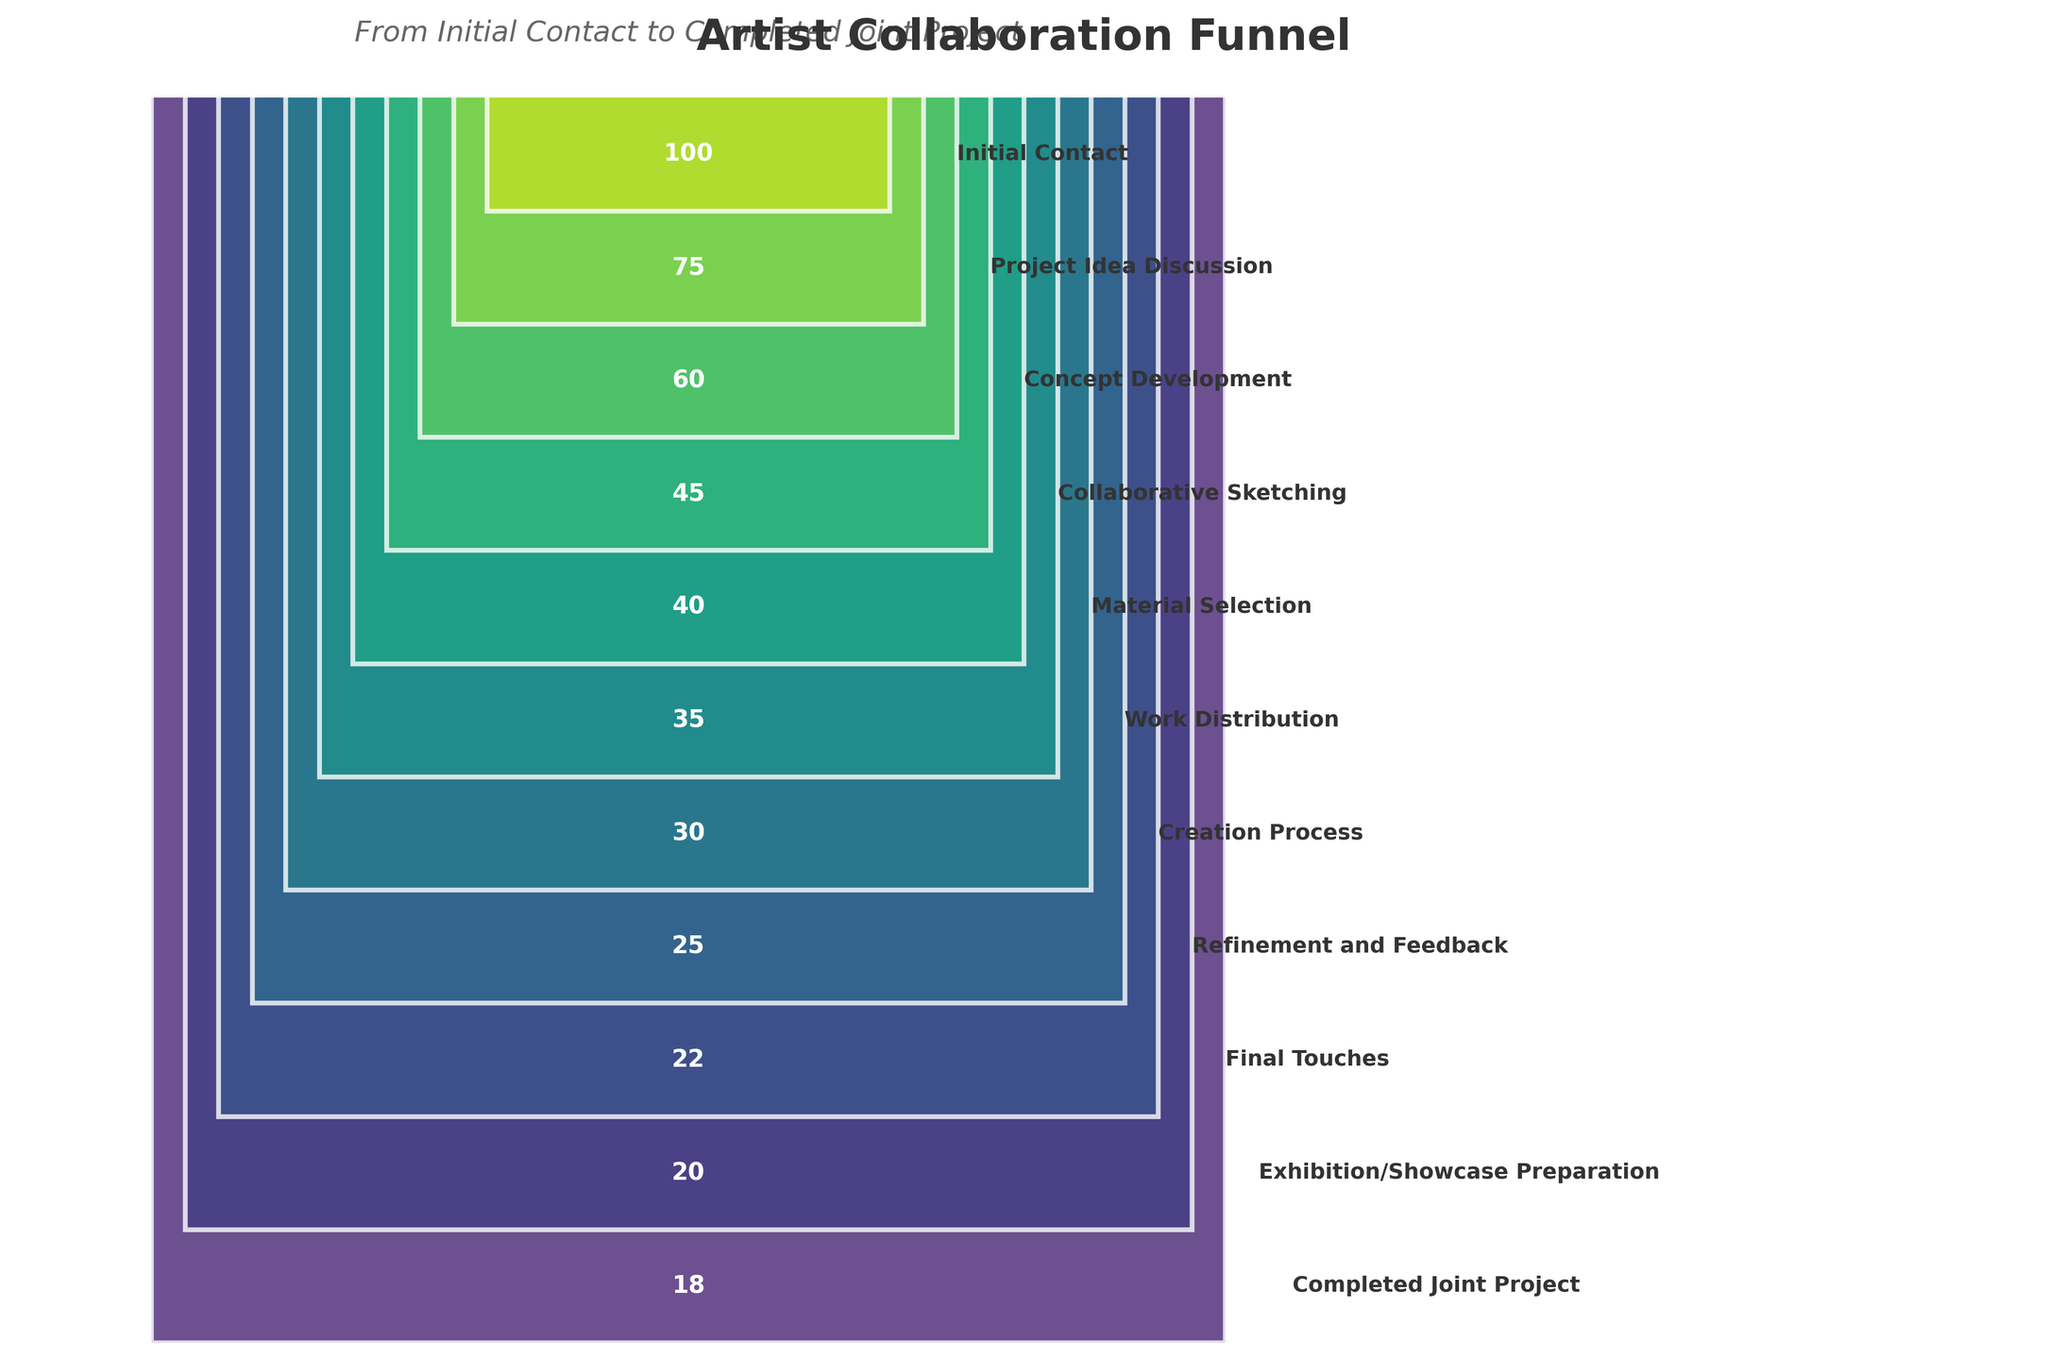What's the title of the funnel chart? The title is usually located at the top of the chart. Here, it reads "Artist Collaboration Funnel".
Answer: Artist Collaboration Funnel How many stages are there in the funnel? By counting the number of bars or sections in the funnel, we can see that there are 11 stages.
Answer: 11 What is the initial number of projects at the "Initial Contact" stage? The number of projects is labeled within the first section of the funnel. The value is 100.
Answer: 100 Which stage has the fewest number of projects? By looking at the narrowest section and the smallest number labeled, the "Completed Joint Project" stage has the fewest number of projects with 18.
Answer: Completed Joint Project How many more projects were there at the "Collaborative Sketching" stage compared to the "Material Selection" stage? The "Collaborative Sketching" stage had 45 projects and the "Material Selection" stage had 40 projects. The difference is 45 - 40 = 5.
Answer: 5 What percentage of the initial projects progressed to the "Completed Joint Project" stage? The initial number of projects is 100 and the completed number is 18. The percentage is (18/100) * 100 = 18%.
Answer: 18% If 3 more projects were added to the "Completed Joint Project" stage, how many would that stage then have? The current number of completed projects is 18. Adding 3 leads to 18 + 3 = 21.
Answer: 21 How many stages see a drop of 10 or more projects from the previous stage? Identify stages where the number decreases by 10 or more: Initial Contact - Project Idea Discussion (100 - 75 = 25), Project Idea Discussion - Concept Development (75 - 60 = 15), Concept Development - Collaborative Sketching (60 - 45 = 15), Collaborative Sketching - Material Selection (45 - 40 = 5), Material Selection - Work Distribution (40 - 35 = 5), Work Distribution - Creation Process (35 - 30 = 5), Creation Process - Refinement and Feedback (30 - 25 = 5), Refinement and Feedback - Final Touches (25 - 22 = 3), Final Touches - Exhibition/Showcase Preparation (22 - 20 = 2), Exhibition/Showcase Preparation - Completed Joint Project (20 - 18 = 2). Only the first three drops are 10 or more.
Answer: 3 What is the total number of projects lost from "Initial Contact" to "Final Touches"? The initial number of projects is 100, and the number at "Final Touches" is 22. The difference is 100 - 22 = 78.
Answer: 78 Compare the drop in the number of projects from "Initial Contact" to "Project Idea Discussion" with the drop from "Concept Development" to "Collaborative Sketching". Which drop is larger? The drop from "Initial Contact" to "Project Idea Discussion" is 100 - 75 = 25. The drop from "Concept Development" to "Collaborative Sketching" is 60 - 45 = 15. The first drop (25) is larger.
Answer: Initial Contact to Project Idea Discussion 